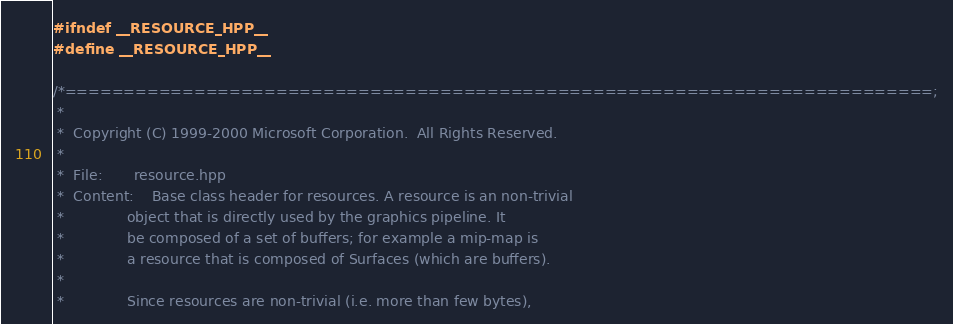Convert code to text. <code><loc_0><loc_0><loc_500><loc_500><_C++_>#ifndef __RESOURCE_HPP__
#define __RESOURCE_HPP__

/*==========================================================================;
 *
 *  Copyright (C) 1999-2000 Microsoft Corporation.  All Rights Reserved.
 *
 *  File:       resource.hpp
 *  Content:    Base class header for resources. A resource is an non-trivial
 *              object that is directly used by the graphics pipeline. It 
 *              be composed of a set of buffers; for example a mip-map is 
 *              a resource that is composed of Surfaces (which are buffers).
 *
 *              Since resources are non-trivial (i.e. more than few bytes), </code> 